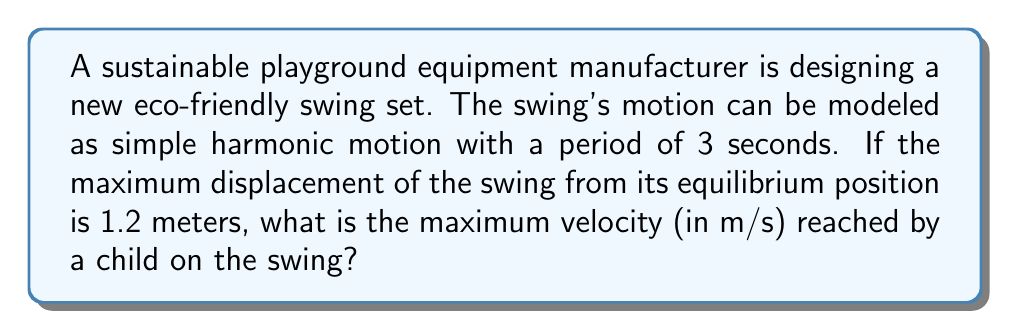Can you answer this question? Let's approach this step-by-step using the equations of simple harmonic motion:

1) The angular frequency $\omega$ of the swing is related to its period $T$ by:
   $$\omega = \frac{2\pi}{T}$$

   With $T = 3$ seconds, we get:
   $$\omega = \frac{2\pi}{3} \approx 2.0944 \text{ rad/s}$$

2) In simple harmonic motion, the displacement $x$ as a function of time $t$ is given by:
   $$x(t) = A \cos(\omega t)$$
   where $A$ is the amplitude (maximum displacement).

3) The velocity $v$ as a function of time is the derivative of displacement:
   $$v(t) = -A\omega \sin(\omega t)$$

4) The maximum velocity occurs when $\sin(\omega t) = \pm 1$, so:
   $$v_{max} = A\omega$$

5) We're given that $A = 1.2$ meters. Substituting this and our calculated $\omega$:
   $$v_{max} = 1.2 \cdot \frac{2\pi}{3} \approx 2.5133 \text{ m/s}$$

Therefore, the maximum velocity reached by a child on the swing is approximately 2.51 m/s.
Answer: 2.51 m/s 